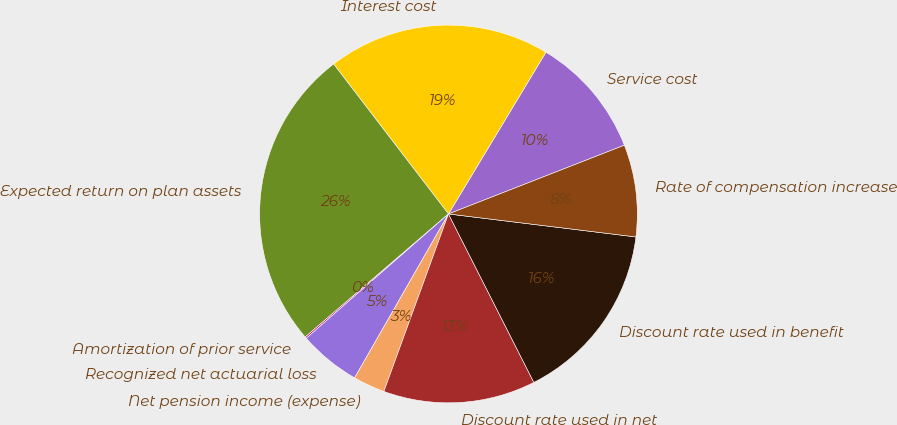Convert chart to OTSL. <chart><loc_0><loc_0><loc_500><loc_500><pie_chart><fcel>Service cost<fcel>Interest cost<fcel>Expected return on plan assets<fcel>Amortization of prior service<fcel>Recognized net actuarial loss<fcel>Net pension income (expense)<fcel>Discount rate used in net<fcel>Discount rate used in benefit<fcel>Rate of compensation increase<nl><fcel>10.44%<fcel>19.03%<fcel>25.89%<fcel>0.14%<fcel>5.29%<fcel>2.72%<fcel>13.02%<fcel>15.59%<fcel>7.87%<nl></chart> 